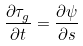Convert formula to latex. <formula><loc_0><loc_0><loc_500><loc_500>\frac { { \partial { \tau _ { g } } } } { \partial t } = \frac { \partial \psi } { \partial s }</formula> 